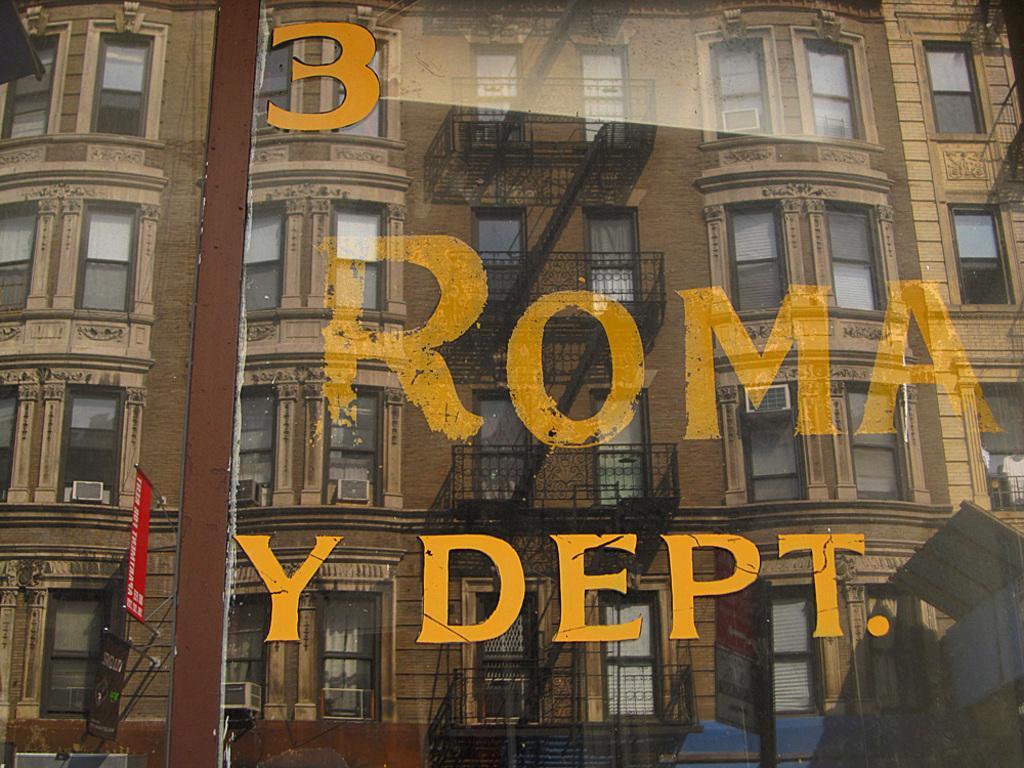Could you give a brief overview of what you see in this image? In this picture we can see building, windows, staircase. On a glass there is something written. On the left side of the picture we can see a red board with poles. 